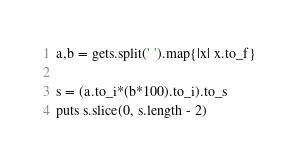<code> <loc_0><loc_0><loc_500><loc_500><_Ruby_>a,b = gets.split(' ').map{|x| x.to_f}

s = (a.to_i*(b*100).to_i).to_s
puts s.slice(0, s.length - 2)
</code> 